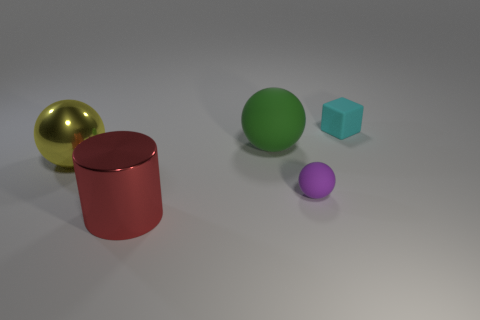Is the number of big green matte objects less than the number of balls?
Provide a succinct answer. Yes. Does the large yellow ball have the same material as the tiny cyan block?
Your answer should be very brief. No. What number of other objects are the same color as the large metallic sphere?
Offer a terse response. 0. Are there more tiny cyan rubber cubes than purple metallic balls?
Offer a very short reply. Yes. There is a green ball; is its size the same as the sphere that is left of the big matte object?
Provide a short and direct response. Yes. What color is the tiny object in front of the large green sphere?
Your answer should be very brief. Purple. What number of blue objects are either small matte things or large balls?
Provide a succinct answer. 0. What color is the big metal ball?
Your answer should be compact. Yellow. Are there fewer shiny cylinders on the left side of the big yellow shiny object than tiny things right of the purple sphere?
Your answer should be compact. Yes. There is a big thing that is both behind the large shiny cylinder and right of the yellow object; what shape is it?
Ensure brevity in your answer.  Sphere. 